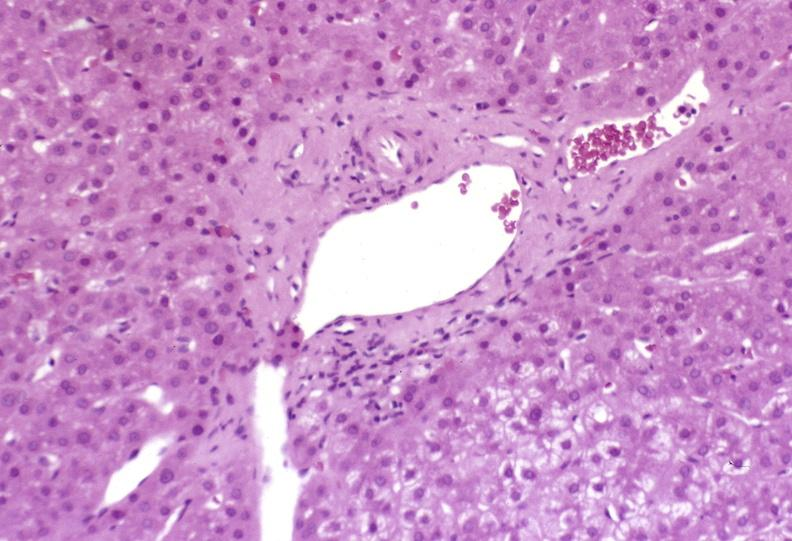what is present?
Answer the question using a single word or phrase. Liver 